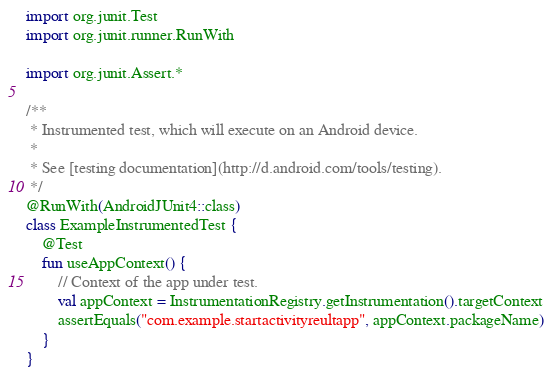Convert code to text. <code><loc_0><loc_0><loc_500><loc_500><_Kotlin_>
import org.junit.Test
import org.junit.runner.RunWith

import org.junit.Assert.*

/**
 * Instrumented test, which will execute on an Android device.
 *
 * See [testing documentation](http://d.android.com/tools/testing).
 */
@RunWith(AndroidJUnit4::class)
class ExampleInstrumentedTest {
    @Test
    fun useAppContext() {
        // Context of the app under test.
        val appContext = InstrumentationRegistry.getInstrumentation().targetContext
        assertEquals("com.example.startactivityreultapp", appContext.packageName)
    }
}
</code> 